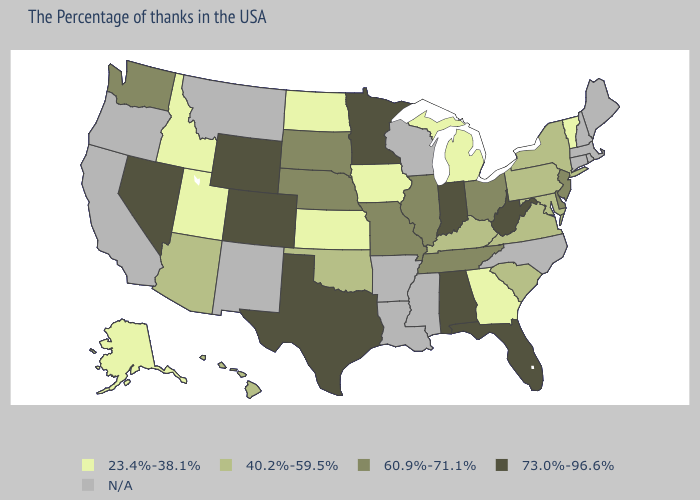What is the lowest value in states that border Texas?
Answer briefly. 40.2%-59.5%. Name the states that have a value in the range 73.0%-96.6%?
Keep it brief. West Virginia, Florida, Indiana, Alabama, Minnesota, Texas, Wyoming, Colorado, Nevada. Does Utah have the lowest value in the West?
Keep it brief. Yes. Does Iowa have the lowest value in the USA?
Give a very brief answer. Yes. Does Wyoming have the highest value in the USA?
Keep it brief. Yes. What is the lowest value in the Northeast?
Concise answer only. 23.4%-38.1%. Among the states that border Kentucky , which have the highest value?
Keep it brief. West Virginia, Indiana. Name the states that have a value in the range 60.9%-71.1%?
Short answer required. New Jersey, Delaware, Ohio, Tennessee, Illinois, Missouri, Nebraska, South Dakota, Washington. What is the value of New Mexico?
Quick response, please. N/A. Name the states that have a value in the range 73.0%-96.6%?
Short answer required. West Virginia, Florida, Indiana, Alabama, Minnesota, Texas, Wyoming, Colorado, Nevada. Among the states that border Missouri , which have the highest value?
Keep it brief. Tennessee, Illinois, Nebraska. What is the value of Vermont?
Answer briefly. 23.4%-38.1%. Which states have the highest value in the USA?
Keep it brief. West Virginia, Florida, Indiana, Alabama, Minnesota, Texas, Wyoming, Colorado, Nevada. What is the value of Arkansas?
Answer briefly. N/A. 